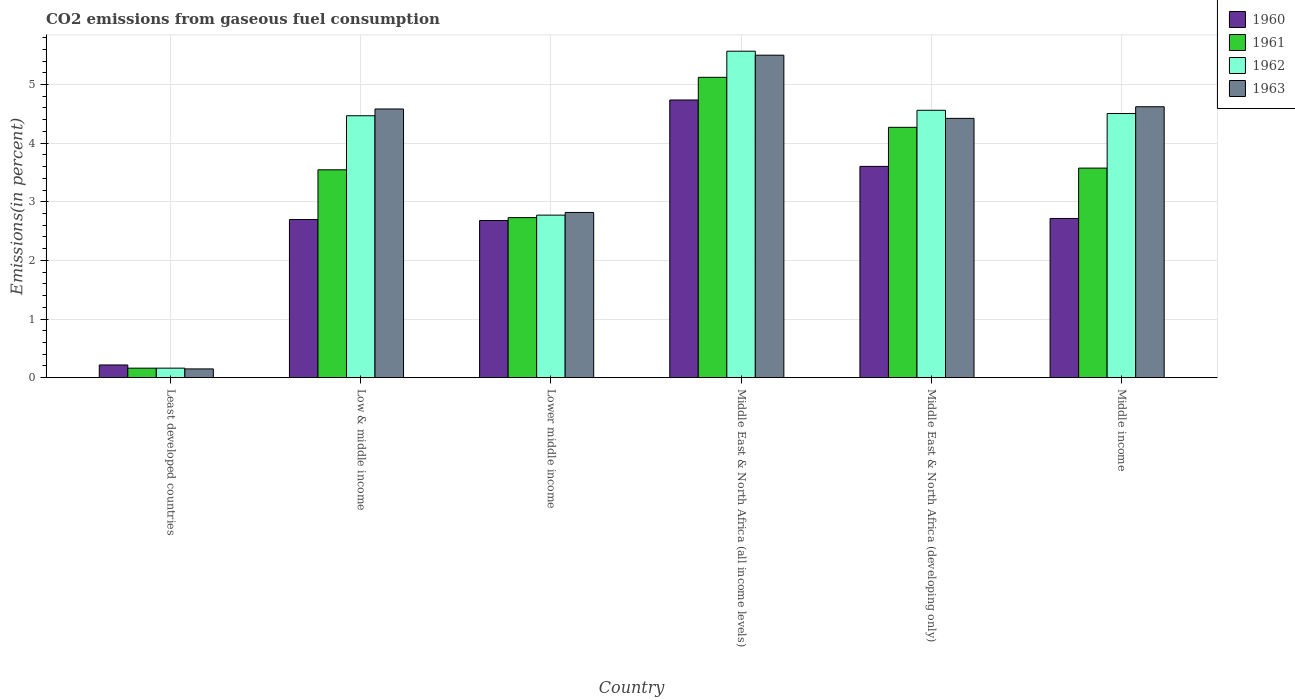How many different coloured bars are there?
Your answer should be compact. 4. How many groups of bars are there?
Keep it short and to the point. 6. Are the number of bars per tick equal to the number of legend labels?
Your answer should be compact. Yes. Are the number of bars on each tick of the X-axis equal?
Provide a short and direct response. Yes. How many bars are there on the 2nd tick from the left?
Keep it short and to the point. 4. What is the label of the 4th group of bars from the left?
Offer a very short reply. Middle East & North Africa (all income levels). What is the total CO2 emitted in 1960 in Middle East & North Africa (all income levels)?
Provide a succinct answer. 4.74. Across all countries, what is the maximum total CO2 emitted in 1961?
Ensure brevity in your answer.  5.12. Across all countries, what is the minimum total CO2 emitted in 1962?
Provide a succinct answer. 0.16. In which country was the total CO2 emitted in 1961 maximum?
Provide a short and direct response. Middle East & North Africa (all income levels). In which country was the total CO2 emitted in 1963 minimum?
Provide a succinct answer. Least developed countries. What is the total total CO2 emitted in 1963 in the graph?
Your response must be concise. 22.09. What is the difference between the total CO2 emitted in 1961 in Least developed countries and that in Middle East & North Africa (developing only)?
Ensure brevity in your answer.  -4.11. What is the difference between the total CO2 emitted in 1962 in Low & middle income and the total CO2 emitted in 1961 in Middle income?
Ensure brevity in your answer.  0.89. What is the average total CO2 emitted in 1962 per country?
Make the answer very short. 3.67. What is the difference between the total CO2 emitted of/in 1960 and total CO2 emitted of/in 1961 in Lower middle income?
Ensure brevity in your answer.  -0.05. In how many countries, is the total CO2 emitted in 1961 greater than 1.8 %?
Your answer should be compact. 5. What is the ratio of the total CO2 emitted in 1961 in Low & middle income to that in Middle East & North Africa (developing only)?
Ensure brevity in your answer.  0.83. Is the difference between the total CO2 emitted in 1960 in Least developed countries and Low & middle income greater than the difference between the total CO2 emitted in 1961 in Least developed countries and Low & middle income?
Give a very brief answer. Yes. What is the difference between the highest and the second highest total CO2 emitted in 1960?
Give a very brief answer. -0.89. What is the difference between the highest and the lowest total CO2 emitted in 1962?
Your answer should be compact. 5.41. Is the sum of the total CO2 emitted in 1962 in Lower middle income and Middle East & North Africa (all income levels) greater than the maximum total CO2 emitted in 1961 across all countries?
Provide a succinct answer. Yes. Is it the case that in every country, the sum of the total CO2 emitted in 1962 and total CO2 emitted in 1960 is greater than the sum of total CO2 emitted in 1963 and total CO2 emitted in 1961?
Make the answer very short. No. What does the 4th bar from the right in Middle East & North Africa (all income levels) represents?
Your answer should be compact. 1960. Is it the case that in every country, the sum of the total CO2 emitted in 1962 and total CO2 emitted in 1963 is greater than the total CO2 emitted in 1961?
Keep it short and to the point. Yes. How many bars are there?
Your response must be concise. 24. Are all the bars in the graph horizontal?
Your answer should be very brief. No. How many countries are there in the graph?
Your answer should be compact. 6. Does the graph contain grids?
Offer a terse response. Yes. How are the legend labels stacked?
Your answer should be very brief. Vertical. What is the title of the graph?
Offer a very short reply. CO2 emissions from gaseous fuel consumption. What is the label or title of the Y-axis?
Make the answer very short. Emissions(in percent). What is the Emissions(in percent) of 1960 in Least developed countries?
Give a very brief answer. 0.22. What is the Emissions(in percent) of 1961 in Least developed countries?
Provide a succinct answer. 0.16. What is the Emissions(in percent) in 1962 in Least developed countries?
Your answer should be very brief. 0.16. What is the Emissions(in percent) in 1963 in Least developed countries?
Offer a very short reply. 0.15. What is the Emissions(in percent) in 1960 in Low & middle income?
Provide a succinct answer. 2.7. What is the Emissions(in percent) of 1961 in Low & middle income?
Offer a terse response. 3.55. What is the Emissions(in percent) in 1962 in Low & middle income?
Your response must be concise. 4.47. What is the Emissions(in percent) of 1963 in Low & middle income?
Your answer should be very brief. 4.58. What is the Emissions(in percent) of 1960 in Lower middle income?
Make the answer very short. 2.68. What is the Emissions(in percent) in 1961 in Lower middle income?
Provide a short and direct response. 2.73. What is the Emissions(in percent) in 1962 in Lower middle income?
Your response must be concise. 2.77. What is the Emissions(in percent) of 1963 in Lower middle income?
Provide a short and direct response. 2.82. What is the Emissions(in percent) of 1960 in Middle East & North Africa (all income levels)?
Ensure brevity in your answer.  4.74. What is the Emissions(in percent) in 1961 in Middle East & North Africa (all income levels)?
Ensure brevity in your answer.  5.12. What is the Emissions(in percent) in 1962 in Middle East & North Africa (all income levels)?
Provide a succinct answer. 5.57. What is the Emissions(in percent) of 1963 in Middle East & North Africa (all income levels)?
Keep it short and to the point. 5.5. What is the Emissions(in percent) of 1960 in Middle East & North Africa (developing only)?
Offer a very short reply. 3.6. What is the Emissions(in percent) in 1961 in Middle East & North Africa (developing only)?
Provide a short and direct response. 4.27. What is the Emissions(in percent) in 1962 in Middle East & North Africa (developing only)?
Provide a succinct answer. 4.56. What is the Emissions(in percent) of 1963 in Middle East & North Africa (developing only)?
Make the answer very short. 4.42. What is the Emissions(in percent) of 1960 in Middle income?
Your answer should be compact. 2.72. What is the Emissions(in percent) in 1961 in Middle income?
Provide a succinct answer. 3.57. What is the Emissions(in percent) of 1962 in Middle income?
Keep it short and to the point. 4.5. What is the Emissions(in percent) in 1963 in Middle income?
Offer a terse response. 4.62. Across all countries, what is the maximum Emissions(in percent) in 1960?
Keep it short and to the point. 4.74. Across all countries, what is the maximum Emissions(in percent) in 1961?
Your answer should be compact. 5.12. Across all countries, what is the maximum Emissions(in percent) in 1962?
Offer a very short reply. 5.57. Across all countries, what is the maximum Emissions(in percent) in 1963?
Provide a succinct answer. 5.5. Across all countries, what is the minimum Emissions(in percent) of 1960?
Your answer should be very brief. 0.22. Across all countries, what is the minimum Emissions(in percent) of 1961?
Give a very brief answer. 0.16. Across all countries, what is the minimum Emissions(in percent) in 1962?
Your answer should be very brief. 0.16. Across all countries, what is the minimum Emissions(in percent) in 1963?
Make the answer very short. 0.15. What is the total Emissions(in percent) of 1960 in the graph?
Make the answer very short. 16.65. What is the total Emissions(in percent) of 1961 in the graph?
Offer a terse response. 19.4. What is the total Emissions(in percent) in 1962 in the graph?
Your answer should be compact. 22.03. What is the total Emissions(in percent) of 1963 in the graph?
Keep it short and to the point. 22.09. What is the difference between the Emissions(in percent) of 1960 in Least developed countries and that in Low & middle income?
Your response must be concise. -2.48. What is the difference between the Emissions(in percent) of 1961 in Least developed countries and that in Low & middle income?
Keep it short and to the point. -3.38. What is the difference between the Emissions(in percent) of 1962 in Least developed countries and that in Low & middle income?
Offer a terse response. -4.31. What is the difference between the Emissions(in percent) of 1963 in Least developed countries and that in Low & middle income?
Your answer should be compact. -4.43. What is the difference between the Emissions(in percent) of 1960 in Least developed countries and that in Lower middle income?
Give a very brief answer. -2.46. What is the difference between the Emissions(in percent) in 1961 in Least developed countries and that in Lower middle income?
Your response must be concise. -2.57. What is the difference between the Emissions(in percent) in 1962 in Least developed countries and that in Lower middle income?
Your answer should be compact. -2.61. What is the difference between the Emissions(in percent) of 1963 in Least developed countries and that in Lower middle income?
Your answer should be very brief. -2.67. What is the difference between the Emissions(in percent) in 1960 in Least developed countries and that in Middle East & North Africa (all income levels)?
Make the answer very short. -4.52. What is the difference between the Emissions(in percent) in 1961 in Least developed countries and that in Middle East & North Africa (all income levels)?
Your answer should be very brief. -4.96. What is the difference between the Emissions(in percent) of 1962 in Least developed countries and that in Middle East & North Africa (all income levels)?
Keep it short and to the point. -5.41. What is the difference between the Emissions(in percent) of 1963 in Least developed countries and that in Middle East & North Africa (all income levels)?
Provide a short and direct response. -5.35. What is the difference between the Emissions(in percent) of 1960 in Least developed countries and that in Middle East & North Africa (developing only)?
Provide a succinct answer. -3.39. What is the difference between the Emissions(in percent) in 1961 in Least developed countries and that in Middle East & North Africa (developing only)?
Your response must be concise. -4.11. What is the difference between the Emissions(in percent) in 1962 in Least developed countries and that in Middle East & North Africa (developing only)?
Your answer should be very brief. -4.4. What is the difference between the Emissions(in percent) in 1963 in Least developed countries and that in Middle East & North Africa (developing only)?
Keep it short and to the point. -4.27. What is the difference between the Emissions(in percent) of 1960 in Least developed countries and that in Middle income?
Your answer should be compact. -2.5. What is the difference between the Emissions(in percent) of 1961 in Least developed countries and that in Middle income?
Offer a terse response. -3.41. What is the difference between the Emissions(in percent) in 1962 in Least developed countries and that in Middle income?
Provide a short and direct response. -4.34. What is the difference between the Emissions(in percent) in 1963 in Least developed countries and that in Middle income?
Your answer should be compact. -4.47. What is the difference between the Emissions(in percent) of 1960 in Low & middle income and that in Lower middle income?
Keep it short and to the point. 0.02. What is the difference between the Emissions(in percent) of 1961 in Low & middle income and that in Lower middle income?
Give a very brief answer. 0.82. What is the difference between the Emissions(in percent) in 1962 in Low & middle income and that in Lower middle income?
Your answer should be compact. 1.7. What is the difference between the Emissions(in percent) of 1963 in Low & middle income and that in Lower middle income?
Provide a short and direct response. 1.76. What is the difference between the Emissions(in percent) of 1960 in Low & middle income and that in Middle East & North Africa (all income levels)?
Keep it short and to the point. -2.04. What is the difference between the Emissions(in percent) in 1961 in Low & middle income and that in Middle East & North Africa (all income levels)?
Give a very brief answer. -1.58. What is the difference between the Emissions(in percent) of 1962 in Low & middle income and that in Middle East & North Africa (all income levels)?
Give a very brief answer. -1.1. What is the difference between the Emissions(in percent) in 1963 in Low & middle income and that in Middle East & North Africa (all income levels)?
Your response must be concise. -0.92. What is the difference between the Emissions(in percent) in 1960 in Low & middle income and that in Middle East & North Africa (developing only)?
Your answer should be compact. -0.91. What is the difference between the Emissions(in percent) in 1961 in Low & middle income and that in Middle East & North Africa (developing only)?
Offer a terse response. -0.72. What is the difference between the Emissions(in percent) of 1962 in Low & middle income and that in Middle East & North Africa (developing only)?
Provide a short and direct response. -0.09. What is the difference between the Emissions(in percent) in 1963 in Low & middle income and that in Middle East & North Africa (developing only)?
Offer a very short reply. 0.16. What is the difference between the Emissions(in percent) of 1960 in Low & middle income and that in Middle income?
Your answer should be very brief. -0.02. What is the difference between the Emissions(in percent) of 1961 in Low & middle income and that in Middle income?
Your response must be concise. -0.03. What is the difference between the Emissions(in percent) of 1962 in Low & middle income and that in Middle income?
Ensure brevity in your answer.  -0.04. What is the difference between the Emissions(in percent) of 1963 in Low & middle income and that in Middle income?
Offer a very short reply. -0.04. What is the difference between the Emissions(in percent) in 1960 in Lower middle income and that in Middle East & North Africa (all income levels)?
Offer a very short reply. -2.06. What is the difference between the Emissions(in percent) in 1961 in Lower middle income and that in Middle East & North Africa (all income levels)?
Your response must be concise. -2.39. What is the difference between the Emissions(in percent) in 1962 in Lower middle income and that in Middle East & North Africa (all income levels)?
Your response must be concise. -2.8. What is the difference between the Emissions(in percent) of 1963 in Lower middle income and that in Middle East & North Africa (all income levels)?
Provide a succinct answer. -2.68. What is the difference between the Emissions(in percent) of 1960 in Lower middle income and that in Middle East & North Africa (developing only)?
Offer a very short reply. -0.92. What is the difference between the Emissions(in percent) in 1961 in Lower middle income and that in Middle East & North Africa (developing only)?
Your answer should be compact. -1.54. What is the difference between the Emissions(in percent) in 1962 in Lower middle income and that in Middle East & North Africa (developing only)?
Your answer should be very brief. -1.79. What is the difference between the Emissions(in percent) in 1963 in Lower middle income and that in Middle East & North Africa (developing only)?
Your response must be concise. -1.6. What is the difference between the Emissions(in percent) in 1960 in Lower middle income and that in Middle income?
Ensure brevity in your answer.  -0.03. What is the difference between the Emissions(in percent) in 1961 in Lower middle income and that in Middle income?
Keep it short and to the point. -0.84. What is the difference between the Emissions(in percent) in 1962 in Lower middle income and that in Middle income?
Your answer should be very brief. -1.73. What is the difference between the Emissions(in percent) in 1963 in Lower middle income and that in Middle income?
Provide a short and direct response. -1.8. What is the difference between the Emissions(in percent) of 1960 in Middle East & North Africa (all income levels) and that in Middle East & North Africa (developing only)?
Ensure brevity in your answer.  1.13. What is the difference between the Emissions(in percent) of 1961 in Middle East & North Africa (all income levels) and that in Middle East & North Africa (developing only)?
Keep it short and to the point. 0.85. What is the difference between the Emissions(in percent) of 1962 in Middle East & North Africa (all income levels) and that in Middle East & North Africa (developing only)?
Offer a terse response. 1.01. What is the difference between the Emissions(in percent) in 1963 in Middle East & North Africa (all income levels) and that in Middle East & North Africa (developing only)?
Make the answer very short. 1.08. What is the difference between the Emissions(in percent) in 1960 in Middle East & North Africa (all income levels) and that in Middle income?
Your answer should be very brief. 2.02. What is the difference between the Emissions(in percent) in 1961 in Middle East & North Africa (all income levels) and that in Middle income?
Offer a very short reply. 1.55. What is the difference between the Emissions(in percent) in 1962 in Middle East & North Africa (all income levels) and that in Middle income?
Your answer should be very brief. 1.06. What is the difference between the Emissions(in percent) of 1963 in Middle East & North Africa (all income levels) and that in Middle income?
Provide a short and direct response. 0.88. What is the difference between the Emissions(in percent) of 1960 in Middle East & North Africa (developing only) and that in Middle income?
Provide a succinct answer. 0.89. What is the difference between the Emissions(in percent) of 1961 in Middle East & North Africa (developing only) and that in Middle income?
Give a very brief answer. 0.7. What is the difference between the Emissions(in percent) of 1962 in Middle East & North Africa (developing only) and that in Middle income?
Offer a very short reply. 0.06. What is the difference between the Emissions(in percent) in 1963 in Middle East & North Africa (developing only) and that in Middle income?
Your answer should be very brief. -0.2. What is the difference between the Emissions(in percent) of 1960 in Least developed countries and the Emissions(in percent) of 1961 in Low & middle income?
Offer a very short reply. -3.33. What is the difference between the Emissions(in percent) of 1960 in Least developed countries and the Emissions(in percent) of 1962 in Low & middle income?
Give a very brief answer. -4.25. What is the difference between the Emissions(in percent) of 1960 in Least developed countries and the Emissions(in percent) of 1963 in Low & middle income?
Your answer should be compact. -4.37. What is the difference between the Emissions(in percent) in 1961 in Least developed countries and the Emissions(in percent) in 1962 in Low & middle income?
Provide a succinct answer. -4.31. What is the difference between the Emissions(in percent) of 1961 in Least developed countries and the Emissions(in percent) of 1963 in Low & middle income?
Give a very brief answer. -4.42. What is the difference between the Emissions(in percent) of 1962 in Least developed countries and the Emissions(in percent) of 1963 in Low & middle income?
Offer a terse response. -4.42. What is the difference between the Emissions(in percent) of 1960 in Least developed countries and the Emissions(in percent) of 1961 in Lower middle income?
Your response must be concise. -2.51. What is the difference between the Emissions(in percent) of 1960 in Least developed countries and the Emissions(in percent) of 1962 in Lower middle income?
Make the answer very short. -2.56. What is the difference between the Emissions(in percent) of 1960 in Least developed countries and the Emissions(in percent) of 1963 in Lower middle income?
Your response must be concise. -2.6. What is the difference between the Emissions(in percent) of 1961 in Least developed countries and the Emissions(in percent) of 1962 in Lower middle income?
Your answer should be compact. -2.61. What is the difference between the Emissions(in percent) in 1961 in Least developed countries and the Emissions(in percent) in 1963 in Lower middle income?
Give a very brief answer. -2.66. What is the difference between the Emissions(in percent) in 1962 in Least developed countries and the Emissions(in percent) in 1963 in Lower middle income?
Give a very brief answer. -2.66. What is the difference between the Emissions(in percent) in 1960 in Least developed countries and the Emissions(in percent) in 1961 in Middle East & North Africa (all income levels)?
Give a very brief answer. -4.91. What is the difference between the Emissions(in percent) in 1960 in Least developed countries and the Emissions(in percent) in 1962 in Middle East & North Africa (all income levels)?
Your answer should be very brief. -5.35. What is the difference between the Emissions(in percent) of 1960 in Least developed countries and the Emissions(in percent) of 1963 in Middle East & North Africa (all income levels)?
Provide a succinct answer. -5.28. What is the difference between the Emissions(in percent) of 1961 in Least developed countries and the Emissions(in percent) of 1962 in Middle East & North Africa (all income levels)?
Your answer should be compact. -5.41. What is the difference between the Emissions(in percent) of 1961 in Least developed countries and the Emissions(in percent) of 1963 in Middle East & North Africa (all income levels)?
Your response must be concise. -5.34. What is the difference between the Emissions(in percent) in 1962 in Least developed countries and the Emissions(in percent) in 1963 in Middle East & North Africa (all income levels)?
Ensure brevity in your answer.  -5.34. What is the difference between the Emissions(in percent) in 1960 in Least developed countries and the Emissions(in percent) in 1961 in Middle East & North Africa (developing only)?
Offer a terse response. -4.05. What is the difference between the Emissions(in percent) in 1960 in Least developed countries and the Emissions(in percent) in 1962 in Middle East & North Africa (developing only)?
Keep it short and to the point. -4.34. What is the difference between the Emissions(in percent) in 1960 in Least developed countries and the Emissions(in percent) in 1963 in Middle East & North Africa (developing only)?
Make the answer very short. -4.21. What is the difference between the Emissions(in percent) of 1961 in Least developed countries and the Emissions(in percent) of 1962 in Middle East & North Africa (developing only)?
Your answer should be compact. -4.4. What is the difference between the Emissions(in percent) in 1961 in Least developed countries and the Emissions(in percent) in 1963 in Middle East & North Africa (developing only)?
Provide a short and direct response. -4.26. What is the difference between the Emissions(in percent) of 1962 in Least developed countries and the Emissions(in percent) of 1963 in Middle East & North Africa (developing only)?
Provide a short and direct response. -4.26. What is the difference between the Emissions(in percent) in 1960 in Least developed countries and the Emissions(in percent) in 1961 in Middle income?
Your response must be concise. -3.36. What is the difference between the Emissions(in percent) in 1960 in Least developed countries and the Emissions(in percent) in 1962 in Middle income?
Offer a very short reply. -4.29. What is the difference between the Emissions(in percent) of 1960 in Least developed countries and the Emissions(in percent) of 1963 in Middle income?
Give a very brief answer. -4.4. What is the difference between the Emissions(in percent) of 1961 in Least developed countries and the Emissions(in percent) of 1962 in Middle income?
Give a very brief answer. -4.34. What is the difference between the Emissions(in percent) in 1961 in Least developed countries and the Emissions(in percent) in 1963 in Middle income?
Make the answer very short. -4.46. What is the difference between the Emissions(in percent) in 1962 in Least developed countries and the Emissions(in percent) in 1963 in Middle income?
Provide a succinct answer. -4.46. What is the difference between the Emissions(in percent) in 1960 in Low & middle income and the Emissions(in percent) in 1961 in Lower middle income?
Provide a short and direct response. -0.03. What is the difference between the Emissions(in percent) in 1960 in Low & middle income and the Emissions(in percent) in 1962 in Lower middle income?
Keep it short and to the point. -0.07. What is the difference between the Emissions(in percent) of 1960 in Low & middle income and the Emissions(in percent) of 1963 in Lower middle income?
Provide a short and direct response. -0.12. What is the difference between the Emissions(in percent) in 1961 in Low & middle income and the Emissions(in percent) in 1962 in Lower middle income?
Make the answer very short. 0.77. What is the difference between the Emissions(in percent) in 1961 in Low & middle income and the Emissions(in percent) in 1963 in Lower middle income?
Your response must be concise. 0.73. What is the difference between the Emissions(in percent) in 1962 in Low & middle income and the Emissions(in percent) in 1963 in Lower middle income?
Keep it short and to the point. 1.65. What is the difference between the Emissions(in percent) in 1960 in Low & middle income and the Emissions(in percent) in 1961 in Middle East & North Africa (all income levels)?
Your answer should be compact. -2.42. What is the difference between the Emissions(in percent) in 1960 in Low & middle income and the Emissions(in percent) in 1962 in Middle East & North Africa (all income levels)?
Make the answer very short. -2.87. What is the difference between the Emissions(in percent) in 1960 in Low & middle income and the Emissions(in percent) in 1963 in Middle East & North Africa (all income levels)?
Ensure brevity in your answer.  -2.8. What is the difference between the Emissions(in percent) of 1961 in Low & middle income and the Emissions(in percent) of 1962 in Middle East & North Africa (all income levels)?
Keep it short and to the point. -2.02. What is the difference between the Emissions(in percent) of 1961 in Low & middle income and the Emissions(in percent) of 1963 in Middle East & North Africa (all income levels)?
Provide a succinct answer. -1.95. What is the difference between the Emissions(in percent) in 1962 in Low & middle income and the Emissions(in percent) in 1963 in Middle East & North Africa (all income levels)?
Provide a short and direct response. -1.03. What is the difference between the Emissions(in percent) of 1960 in Low & middle income and the Emissions(in percent) of 1961 in Middle East & North Africa (developing only)?
Provide a short and direct response. -1.57. What is the difference between the Emissions(in percent) of 1960 in Low & middle income and the Emissions(in percent) of 1962 in Middle East & North Africa (developing only)?
Your answer should be compact. -1.86. What is the difference between the Emissions(in percent) in 1960 in Low & middle income and the Emissions(in percent) in 1963 in Middle East & North Africa (developing only)?
Make the answer very short. -1.72. What is the difference between the Emissions(in percent) of 1961 in Low & middle income and the Emissions(in percent) of 1962 in Middle East & North Africa (developing only)?
Keep it short and to the point. -1.01. What is the difference between the Emissions(in percent) in 1961 in Low & middle income and the Emissions(in percent) in 1963 in Middle East & North Africa (developing only)?
Offer a very short reply. -0.88. What is the difference between the Emissions(in percent) in 1962 in Low & middle income and the Emissions(in percent) in 1963 in Middle East & North Africa (developing only)?
Give a very brief answer. 0.04. What is the difference between the Emissions(in percent) in 1960 in Low & middle income and the Emissions(in percent) in 1961 in Middle income?
Offer a very short reply. -0.88. What is the difference between the Emissions(in percent) in 1960 in Low & middle income and the Emissions(in percent) in 1962 in Middle income?
Offer a very short reply. -1.81. What is the difference between the Emissions(in percent) of 1960 in Low & middle income and the Emissions(in percent) of 1963 in Middle income?
Your answer should be compact. -1.92. What is the difference between the Emissions(in percent) in 1961 in Low & middle income and the Emissions(in percent) in 1962 in Middle income?
Provide a succinct answer. -0.96. What is the difference between the Emissions(in percent) of 1961 in Low & middle income and the Emissions(in percent) of 1963 in Middle income?
Your answer should be compact. -1.08. What is the difference between the Emissions(in percent) of 1962 in Low & middle income and the Emissions(in percent) of 1963 in Middle income?
Provide a short and direct response. -0.15. What is the difference between the Emissions(in percent) in 1960 in Lower middle income and the Emissions(in percent) in 1961 in Middle East & North Africa (all income levels)?
Give a very brief answer. -2.44. What is the difference between the Emissions(in percent) in 1960 in Lower middle income and the Emissions(in percent) in 1962 in Middle East & North Africa (all income levels)?
Your answer should be compact. -2.89. What is the difference between the Emissions(in percent) of 1960 in Lower middle income and the Emissions(in percent) of 1963 in Middle East & North Africa (all income levels)?
Keep it short and to the point. -2.82. What is the difference between the Emissions(in percent) of 1961 in Lower middle income and the Emissions(in percent) of 1962 in Middle East & North Africa (all income levels)?
Your answer should be compact. -2.84. What is the difference between the Emissions(in percent) of 1961 in Lower middle income and the Emissions(in percent) of 1963 in Middle East & North Africa (all income levels)?
Give a very brief answer. -2.77. What is the difference between the Emissions(in percent) of 1962 in Lower middle income and the Emissions(in percent) of 1963 in Middle East & North Africa (all income levels)?
Ensure brevity in your answer.  -2.73. What is the difference between the Emissions(in percent) in 1960 in Lower middle income and the Emissions(in percent) in 1961 in Middle East & North Africa (developing only)?
Give a very brief answer. -1.59. What is the difference between the Emissions(in percent) of 1960 in Lower middle income and the Emissions(in percent) of 1962 in Middle East & North Africa (developing only)?
Your answer should be very brief. -1.88. What is the difference between the Emissions(in percent) in 1960 in Lower middle income and the Emissions(in percent) in 1963 in Middle East & North Africa (developing only)?
Ensure brevity in your answer.  -1.74. What is the difference between the Emissions(in percent) in 1961 in Lower middle income and the Emissions(in percent) in 1962 in Middle East & North Africa (developing only)?
Ensure brevity in your answer.  -1.83. What is the difference between the Emissions(in percent) of 1961 in Lower middle income and the Emissions(in percent) of 1963 in Middle East & North Africa (developing only)?
Offer a very short reply. -1.69. What is the difference between the Emissions(in percent) in 1962 in Lower middle income and the Emissions(in percent) in 1963 in Middle East & North Africa (developing only)?
Provide a succinct answer. -1.65. What is the difference between the Emissions(in percent) of 1960 in Lower middle income and the Emissions(in percent) of 1961 in Middle income?
Ensure brevity in your answer.  -0.89. What is the difference between the Emissions(in percent) in 1960 in Lower middle income and the Emissions(in percent) in 1962 in Middle income?
Your answer should be compact. -1.82. What is the difference between the Emissions(in percent) in 1960 in Lower middle income and the Emissions(in percent) in 1963 in Middle income?
Ensure brevity in your answer.  -1.94. What is the difference between the Emissions(in percent) in 1961 in Lower middle income and the Emissions(in percent) in 1962 in Middle income?
Provide a short and direct response. -1.78. What is the difference between the Emissions(in percent) of 1961 in Lower middle income and the Emissions(in percent) of 1963 in Middle income?
Offer a terse response. -1.89. What is the difference between the Emissions(in percent) of 1962 in Lower middle income and the Emissions(in percent) of 1963 in Middle income?
Ensure brevity in your answer.  -1.85. What is the difference between the Emissions(in percent) in 1960 in Middle East & North Africa (all income levels) and the Emissions(in percent) in 1961 in Middle East & North Africa (developing only)?
Your response must be concise. 0.47. What is the difference between the Emissions(in percent) of 1960 in Middle East & North Africa (all income levels) and the Emissions(in percent) of 1962 in Middle East & North Africa (developing only)?
Give a very brief answer. 0.18. What is the difference between the Emissions(in percent) in 1960 in Middle East & North Africa (all income levels) and the Emissions(in percent) in 1963 in Middle East & North Africa (developing only)?
Provide a short and direct response. 0.31. What is the difference between the Emissions(in percent) of 1961 in Middle East & North Africa (all income levels) and the Emissions(in percent) of 1962 in Middle East & North Africa (developing only)?
Your answer should be compact. 0.56. What is the difference between the Emissions(in percent) in 1961 in Middle East & North Africa (all income levels) and the Emissions(in percent) in 1963 in Middle East & North Africa (developing only)?
Your answer should be very brief. 0.7. What is the difference between the Emissions(in percent) of 1962 in Middle East & North Africa (all income levels) and the Emissions(in percent) of 1963 in Middle East & North Africa (developing only)?
Offer a terse response. 1.15. What is the difference between the Emissions(in percent) of 1960 in Middle East & North Africa (all income levels) and the Emissions(in percent) of 1961 in Middle income?
Provide a succinct answer. 1.16. What is the difference between the Emissions(in percent) of 1960 in Middle East & North Africa (all income levels) and the Emissions(in percent) of 1962 in Middle income?
Your response must be concise. 0.23. What is the difference between the Emissions(in percent) in 1960 in Middle East & North Africa (all income levels) and the Emissions(in percent) in 1963 in Middle income?
Offer a very short reply. 0.12. What is the difference between the Emissions(in percent) of 1961 in Middle East & North Africa (all income levels) and the Emissions(in percent) of 1962 in Middle income?
Make the answer very short. 0.62. What is the difference between the Emissions(in percent) in 1961 in Middle East & North Africa (all income levels) and the Emissions(in percent) in 1963 in Middle income?
Provide a short and direct response. 0.5. What is the difference between the Emissions(in percent) in 1962 in Middle East & North Africa (all income levels) and the Emissions(in percent) in 1963 in Middle income?
Make the answer very short. 0.95. What is the difference between the Emissions(in percent) in 1960 in Middle East & North Africa (developing only) and the Emissions(in percent) in 1961 in Middle income?
Offer a very short reply. 0.03. What is the difference between the Emissions(in percent) of 1960 in Middle East & North Africa (developing only) and the Emissions(in percent) of 1962 in Middle income?
Give a very brief answer. -0.9. What is the difference between the Emissions(in percent) in 1960 in Middle East & North Africa (developing only) and the Emissions(in percent) in 1963 in Middle income?
Ensure brevity in your answer.  -1.02. What is the difference between the Emissions(in percent) in 1961 in Middle East & North Africa (developing only) and the Emissions(in percent) in 1962 in Middle income?
Ensure brevity in your answer.  -0.24. What is the difference between the Emissions(in percent) of 1961 in Middle East & North Africa (developing only) and the Emissions(in percent) of 1963 in Middle income?
Provide a short and direct response. -0.35. What is the difference between the Emissions(in percent) in 1962 in Middle East & North Africa (developing only) and the Emissions(in percent) in 1963 in Middle income?
Your answer should be compact. -0.06. What is the average Emissions(in percent) of 1960 per country?
Your answer should be very brief. 2.77. What is the average Emissions(in percent) in 1961 per country?
Ensure brevity in your answer.  3.23. What is the average Emissions(in percent) in 1962 per country?
Make the answer very short. 3.67. What is the average Emissions(in percent) in 1963 per country?
Offer a terse response. 3.68. What is the difference between the Emissions(in percent) of 1960 and Emissions(in percent) of 1961 in Least developed countries?
Your answer should be compact. 0.05. What is the difference between the Emissions(in percent) of 1960 and Emissions(in percent) of 1962 in Least developed countries?
Your answer should be very brief. 0.05. What is the difference between the Emissions(in percent) in 1960 and Emissions(in percent) in 1963 in Least developed countries?
Ensure brevity in your answer.  0.07. What is the difference between the Emissions(in percent) of 1961 and Emissions(in percent) of 1962 in Least developed countries?
Your answer should be compact. -0. What is the difference between the Emissions(in percent) of 1961 and Emissions(in percent) of 1963 in Least developed countries?
Ensure brevity in your answer.  0.01. What is the difference between the Emissions(in percent) in 1962 and Emissions(in percent) in 1963 in Least developed countries?
Your response must be concise. 0.01. What is the difference between the Emissions(in percent) of 1960 and Emissions(in percent) of 1961 in Low & middle income?
Your answer should be compact. -0.85. What is the difference between the Emissions(in percent) of 1960 and Emissions(in percent) of 1962 in Low & middle income?
Offer a terse response. -1.77. What is the difference between the Emissions(in percent) of 1960 and Emissions(in percent) of 1963 in Low & middle income?
Your answer should be very brief. -1.88. What is the difference between the Emissions(in percent) of 1961 and Emissions(in percent) of 1962 in Low & middle income?
Make the answer very short. -0.92. What is the difference between the Emissions(in percent) of 1961 and Emissions(in percent) of 1963 in Low & middle income?
Your response must be concise. -1.04. What is the difference between the Emissions(in percent) in 1962 and Emissions(in percent) in 1963 in Low & middle income?
Offer a very short reply. -0.12. What is the difference between the Emissions(in percent) in 1960 and Emissions(in percent) in 1961 in Lower middle income?
Make the answer very short. -0.05. What is the difference between the Emissions(in percent) in 1960 and Emissions(in percent) in 1962 in Lower middle income?
Provide a short and direct response. -0.09. What is the difference between the Emissions(in percent) in 1960 and Emissions(in percent) in 1963 in Lower middle income?
Give a very brief answer. -0.14. What is the difference between the Emissions(in percent) of 1961 and Emissions(in percent) of 1962 in Lower middle income?
Your response must be concise. -0.04. What is the difference between the Emissions(in percent) of 1961 and Emissions(in percent) of 1963 in Lower middle income?
Your answer should be very brief. -0.09. What is the difference between the Emissions(in percent) in 1962 and Emissions(in percent) in 1963 in Lower middle income?
Offer a very short reply. -0.05. What is the difference between the Emissions(in percent) in 1960 and Emissions(in percent) in 1961 in Middle East & North Africa (all income levels)?
Offer a very short reply. -0.39. What is the difference between the Emissions(in percent) in 1960 and Emissions(in percent) in 1962 in Middle East & North Africa (all income levels)?
Offer a very short reply. -0.83. What is the difference between the Emissions(in percent) in 1960 and Emissions(in percent) in 1963 in Middle East & North Africa (all income levels)?
Your answer should be compact. -0.76. What is the difference between the Emissions(in percent) of 1961 and Emissions(in percent) of 1962 in Middle East & North Africa (all income levels)?
Your response must be concise. -0.45. What is the difference between the Emissions(in percent) in 1961 and Emissions(in percent) in 1963 in Middle East & North Africa (all income levels)?
Your answer should be very brief. -0.38. What is the difference between the Emissions(in percent) in 1962 and Emissions(in percent) in 1963 in Middle East & North Africa (all income levels)?
Offer a very short reply. 0.07. What is the difference between the Emissions(in percent) of 1960 and Emissions(in percent) of 1961 in Middle East & North Africa (developing only)?
Your answer should be compact. -0.67. What is the difference between the Emissions(in percent) of 1960 and Emissions(in percent) of 1962 in Middle East & North Africa (developing only)?
Offer a terse response. -0.96. What is the difference between the Emissions(in percent) of 1960 and Emissions(in percent) of 1963 in Middle East & North Africa (developing only)?
Ensure brevity in your answer.  -0.82. What is the difference between the Emissions(in percent) in 1961 and Emissions(in percent) in 1962 in Middle East & North Africa (developing only)?
Ensure brevity in your answer.  -0.29. What is the difference between the Emissions(in percent) of 1961 and Emissions(in percent) of 1963 in Middle East & North Africa (developing only)?
Your response must be concise. -0.15. What is the difference between the Emissions(in percent) in 1962 and Emissions(in percent) in 1963 in Middle East & North Africa (developing only)?
Ensure brevity in your answer.  0.14. What is the difference between the Emissions(in percent) of 1960 and Emissions(in percent) of 1961 in Middle income?
Keep it short and to the point. -0.86. What is the difference between the Emissions(in percent) of 1960 and Emissions(in percent) of 1962 in Middle income?
Keep it short and to the point. -1.79. What is the difference between the Emissions(in percent) in 1960 and Emissions(in percent) in 1963 in Middle income?
Provide a succinct answer. -1.91. What is the difference between the Emissions(in percent) of 1961 and Emissions(in percent) of 1962 in Middle income?
Keep it short and to the point. -0.93. What is the difference between the Emissions(in percent) in 1961 and Emissions(in percent) in 1963 in Middle income?
Your answer should be compact. -1.05. What is the difference between the Emissions(in percent) in 1962 and Emissions(in percent) in 1963 in Middle income?
Your answer should be compact. -0.12. What is the ratio of the Emissions(in percent) of 1960 in Least developed countries to that in Low & middle income?
Give a very brief answer. 0.08. What is the ratio of the Emissions(in percent) of 1961 in Least developed countries to that in Low & middle income?
Keep it short and to the point. 0.05. What is the ratio of the Emissions(in percent) of 1962 in Least developed countries to that in Low & middle income?
Provide a short and direct response. 0.04. What is the ratio of the Emissions(in percent) in 1963 in Least developed countries to that in Low & middle income?
Provide a short and direct response. 0.03. What is the ratio of the Emissions(in percent) of 1960 in Least developed countries to that in Lower middle income?
Your answer should be compact. 0.08. What is the ratio of the Emissions(in percent) of 1961 in Least developed countries to that in Lower middle income?
Offer a terse response. 0.06. What is the ratio of the Emissions(in percent) in 1962 in Least developed countries to that in Lower middle income?
Provide a short and direct response. 0.06. What is the ratio of the Emissions(in percent) of 1963 in Least developed countries to that in Lower middle income?
Make the answer very short. 0.05. What is the ratio of the Emissions(in percent) of 1960 in Least developed countries to that in Middle East & North Africa (all income levels)?
Ensure brevity in your answer.  0.05. What is the ratio of the Emissions(in percent) of 1961 in Least developed countries to that in Middle East & North Africa (all income levels)?
Your answer should be compact. 0.03. What is the ratio of the Emissions(in percent) in 1962 in Least developed countries to that in Middle East & North Africa (all income levels)?
Keep it short and to the point. 0.03. What is the ratio of the Emissions(in percent) of 1963 in Least developed countries to that in Middle East & North Africa (all income levels)?
Ensure brevity in your answer.  0.03. What is the ratio of the Emissions(in percent) in 1960 in Least developed countries to that in Middle East & North Africa (developing only)?
Provide a short and direct response. 0.06. What is the ratio of the Emissions(in percent) in 1961 in Least developed countries to that in Middle East & North Africa (developing only)?
Provide a short and direct response. 0.04. What is the ratio of the Emissions(in percent) of 1962 in Least developed countries to that in Middle East & North Africa (developing only)?
Keep it short and to the point. 0.04. What is the ratio of the Emissions(in percent) in 1963 in Least developed countries to that in Middle East & North Africa (developing only)?
Make the answer very short. 0.03. What is the ratio of the Emissions(in percent) of 1960 in Least developed countries to that in Middle income?
Keep it short and to the point. 0.08. What is the ratio of the Emissions(in percent) in 1961 in Least developed countries to that in Middle income?
Provide a succinct answer. 0.05. What is the ratio of the Emissions(in percent) of 1962 in Least developed countries to that in Middle income?
Make the answer very short. 0.04. What is the ratio of the Emissions(in percent) of 1963 in Least developed countries to that in Middle income?
Keep it short and to the point. 0.03. What is the ratio of the Emissions(in percent) in 1961 in Low & middle income to that in Lower middle income?
Your answer should be very brief. 1.3. What is the ratio of the Emissions(in percent) of 1962 in Low & middle income to that in Lower middle income?
Make the answer very short. 1.61. What is the ratio of the Emissions(in percent) in 1963 in Low & middle income to that in Lower middle income?
Your response must be concise. 1.63. What is the ratio of the Emissions(in percent) of 1960 in Low & middle income to that in Middle East & North Africa (all income levels)?
Provide a short and direct response. 0.57. What is the ratio of the Emissions(in percent) in 1961 in Low & middle income to that in Middle East & North Africa (all income levels)?
Keep it short and to the point. 0.69. What is the ratio of the Emissions(in percent) in 1962 in Low & middle income to that in Middle East & North Africa (all income levels)?
Your response must be concise. 0.8. What is the ratio of the Emissions(in percent) in 1963 in Low & middle income to that in Middle East & North Africa (all income levels)?
Provide a short and direct response. 0.83. What is the ratio of the Emissions(in percent) in 1960 in Low & middle income to that in Middle East & North Africa (developing only)?
Your answer should be very brief. 0.75. What is the ratio of the Emissions(in percent) in 1961 in Low & middle income to that in Middle East & North Africa (developing only)?
Your answer should be compact. 0.83. What is the ratio of the Emissions(in percent) in 1962 in Low & middle income to that in Middle East & North Africa (developing only)?
Provide a succinct answer. 0.98. What is the ratio of the Emissions(in percent) in 1963 in Low & middle income to that in Middle East & North Africa (developing only)?
Offer a very short reply. 1.04. What is the ratio of the Emissions(in percent) in 1960 in Low & middle income to that in Middle income?
Keep it short and to the point. 0.99. What is the ratio of the Emissions(in percent) of 1962 in Low & middle income to that in Middle income?
Make the answer very short. 0.99. What is the ratio of the Emissions(in percent) in 1963 in Low & middle income to that in Middle income?
Provide a succinct answer. 0.99. What is the ratio of the Emissions(in percent) in 1960 in Lower middle income to that in Middle East & North Africa (all income levels)?
Provide a short and direct response. 0.57. What is the ratio of the Emissions(in percent) in 1961 in Lower middle income to that in Middle East & North Africa (all income levels)?
Your response must be concise. 0.53. What is the ratio of the Emissions(in percent) in 1962 in Lower middle income to that in Middle East & North Africa (all income levels)?
Your response must be concise. 0.5. What is the ratio of the Emissions(in percent) in 1963 in Lower middle income to that in Middle East & North Africa (all income levels)?
Ensure brevity in your answer.  0.51. What is the ratio of the Emissions(in percent) in 1960 in Lower middle income to that in Middle East & North Africa (developing only)?
Keep it short and to the point. 0.74. What is the ratio of the Emissions(in percent) of 1961 in Lower middle income to that in Middle East & North Africa (developing only)?
Your answer should be compact. 0.64. What is the ratio of the Emissions(in percent) in 1962 in Lower middle income to that in Middle East & North Africa (developing only)?
Your answer should be compact. 0.61. What is the ratio of the Emissions(in percent) in 1963 in Lower middle income to that in Middle East & North Africa (developing only)?
Give a very brief answer. 0.64. What is the ratio of the Emissions(in percent) in 1960 in Lower middle income to that in Middle income?
Give a very brief answer. 0.99. What is the ratio of the Emissions(in percent) in 1961 in Lower middle income to that in Middle income?
Your response must be concise. 0.76. What is the ratio of the Emissions(in percent) of 1962 in Lower middle income to that in Middle income?
Offer a terse response. 0.62. What is the ratio of the Emissions(in percent) in 1963 in Lower middle income to that in Middle income?
Offer a terse response. 0.61. What is the ratio of the Emissions(in percent) of 1960 in Middle East & North Africa (all income levels) to that in Middle East & North Africa (developing only)?
Make the answer very short. 1.31. What is the ratio of the Emissions(in percent) in 1961 in Middle East & North Africa (all income levels) to that in Middle East & North Africa (developing only)?
Offer a terse response. 1.2. What is the ratio of the Emissions(in percent) in 1962 in Middle East & North Africa (all income levels) to that in Middle East & North Africa (developing only)?
Offer a terse response. 1.22. What is the ratio of the Emissions(in percent) in 1963 in Middle East & North Africa (all income levels) to that in Middle East & North Africa (developing only)?
Keep it short and to the point. 1.24. What is the ratio of the Emissions(in percent) of 1960 in Middle East & North Africa (all income levels) to that in Middle income?
Your response must be concise. 1.74. What is the ratio of the Emissions(in percent) in 1961 in Middle East & North Africa (all income levels) to that in Middle income?
Provide a short and direct response. 1.43. What is the ratio of the Emissions(in percent) of 1962 in Middle East & North Africa (all income levels) to that in Middle income?
Offer a terse response. 1.24. What is the ratio of the Emissions(in percent) of 1963 in Middle East & North Africa (all income levels) to that in Middle income?
Offer a terse response. 1.19. What is the ratio of the Emissions(in percent) of 1960 in Middle East & North Africa (developing only) to that in Middle income?
Your answer should be very brief. 1.33. What is the ratio of the Emissions(in percent) in 1961 in Middle East & North Africa (developing only) to that in Middle income?
Your response must be concise. 1.19. What is the ratio of the Emissions(in percent) of 1962 in Middle East & North Africa (developing only) to that in Middle income?
Keep it short and to the point. 1.01. What is the ratio of the Emissions(in percent) of 1963 in Middle East & North Africa (developing only) to that in Middle income?
Provide a succinct answer. 0.96. What is the difference between the highest and the second highest Emissions(in percent) of 1960?
Keep it short and to the point. 1.13. What is the difference between the highest and the second highest Emissions(in percent) of 1961?
Offer a very short reply. 0.85. What is the difference between the highest and the second highest Emissions(in percent) in 1962?
Your response must be concise. 1.01. What is the difference between the highest and the second highest Emissions(in percent) of 1963?
Ensure brevity in your answer.  0.88. What is the difference between the highest and the lowest Emissions(in percent) of 1960?
Your answer should be compact. 4.52. What is the difference between the highest and the lowest Emissions(in percent) of 1961?
Ensure brevity in your answer.  4.96. What is the difference between the highest and the lowest Emissions(in percent) of 1962?
Offer a very short reply. 5.41. What is the difference between the highest and the lowest Emissions(in percent) of 1963?
Your response must be concise. 5.35. 